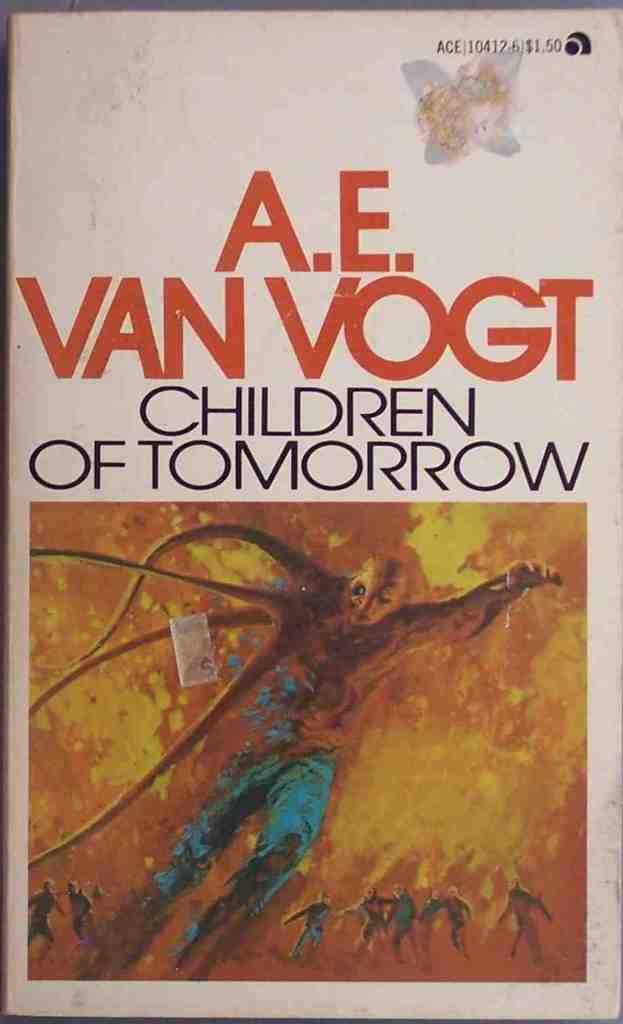Provide a one-sentence caption for the provided image. A book by A.E. Van Vogt called Children of tomorrow. 